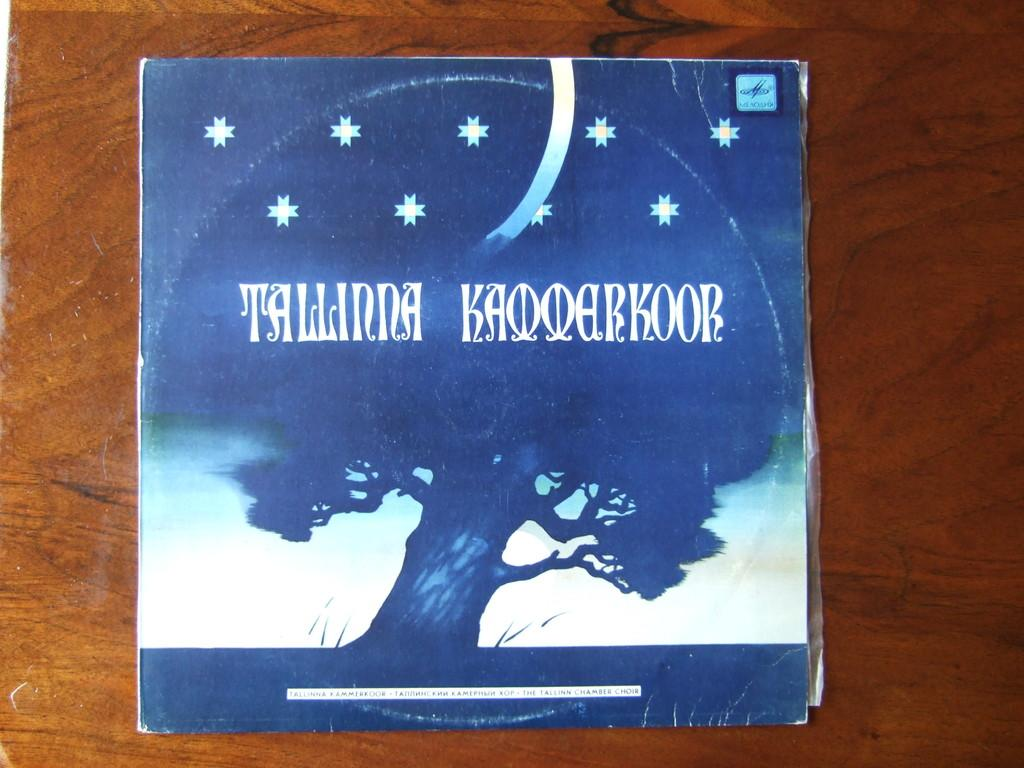<image>
Present a compact description of the photo's key features. A Tallinna Kammerkoor vinyl record sleeve sits on a table. 